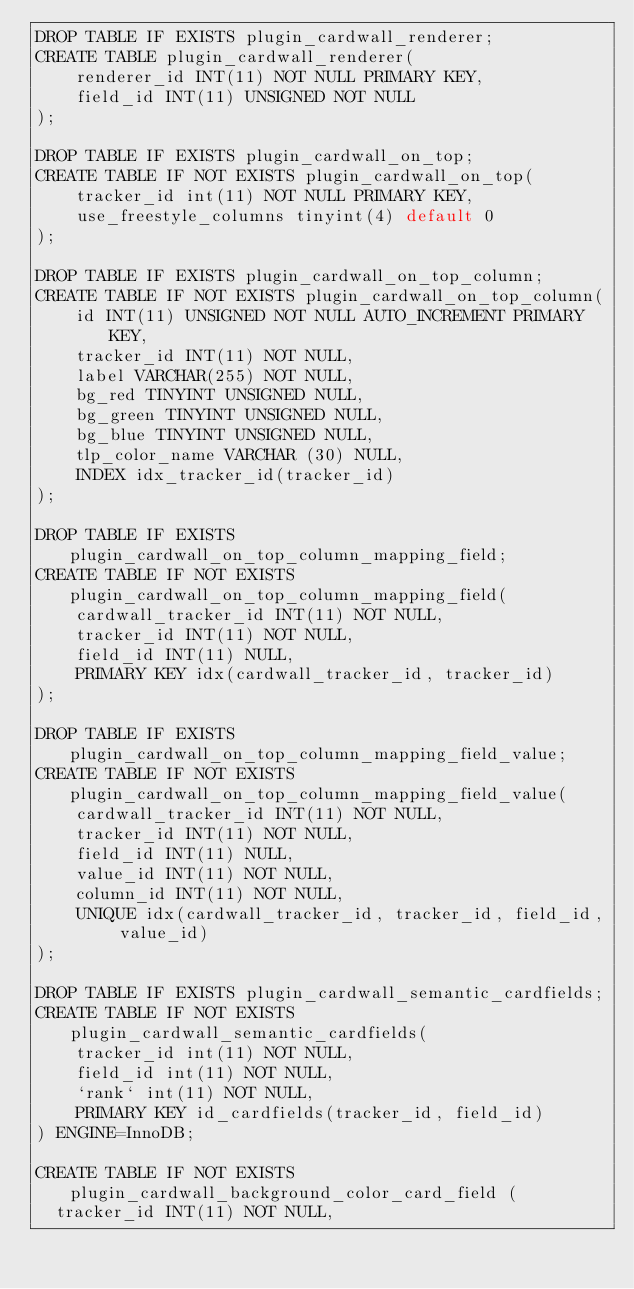<code> <loc_0><loc_0><loc_500><loc_500><_SQL_>DROP TABLE IF EXISTS plugin_cardwall_renderer;
CREATE TABLE plugin_cardwall_renderer(
    renderer_id INT(11) NOT NULL PRIMARY KEY,
    field_id INT(11) UNSIGNED NOT NULL
);

DROP TABLE IF EXISTS plugin_cardwall_on_top;
CREATE TABLE IF NOT EXISTS plugin_cardwall_on_top(
    tracker_id int(11) NOT NULL PRIMARY KEY,
    use_freestyle_columns tinyint(4) default 0
);

DROP TABLE IF EXISTS plugin_cardwall_on_top_column;
CREATE TABLE IF NOT EXISTS plugin_cardwall_on_top_column(
    id INT(11) UNSIGNED NOT NULL AUTO_INCREMENT PRIMARY KEY,
    tracker_id INT(11) NOT NULL,
    label VARCHAR(255) NOT NULL,
    bg_red TINYINT UNSIGNED NULL,
    bg_green TINYINT UNSIGNED NULL,
    bg_blue TINYINT UNSIGNED NULL,
    tlp_color_name VARCHAR (30) NULL,
    INDEX idx_tracker_id(tracker_id)
);

DROP TABLE IF EXISTS plugin_cardwall_on_top_column_mapping_field;
CREATE TABLE IF NOT EXISTS plugin_cardwall_on_top_column_mapping_field(
    cardwall_tracker_id INT(11) NOT NULL,
    tracker_id INT(11) NOT NULL,
    field_id INT(11) NULL,
    PRIMARY KEY idx(cardwall_tracker_id, tracker_id)
);

DROP TABLE IF EXISTS plugin_cardwall_on_top_column_mapping_field_value;
CREATE TABLE IF NOT EXISTS plugin_cardwall_on_top_column_mapping_field_value(
    cardwall_tracker_id INT(11) NOT NULL,
    tracker_id INT(11) NOT NULL,
    field_id INT(11) NULL,
    value_id INT(11) NOT NULL,
    column_id INT(11) NOT NULL,
    UNIQUE idx(cardwall_tracker_id, tracker_id, field_id, value_id)
);

DROP TABLE IF EXISTS plugin_cardwall_semantic_cardfields;
CREATE TABLE IF NOT EXISTS plugin_cardwall_semantic_cardfields(
    tracker_id int(11) NOT NULL,
    field_id int(11) NOT NULL,
    `rank` int(11) NOT NULL,
    PRIMARY KEY id_cardfields(tracker_id, field_id)
) ENGINE=InnoDB;

CREATE TABLE IF NOT EXISTS plugin_cardwall_background_color_card_field (
  tracker_id INT(11) NOT NULL,</code> 